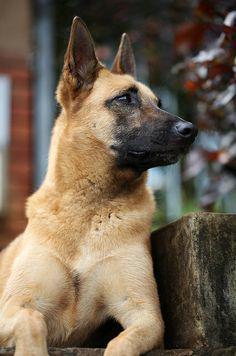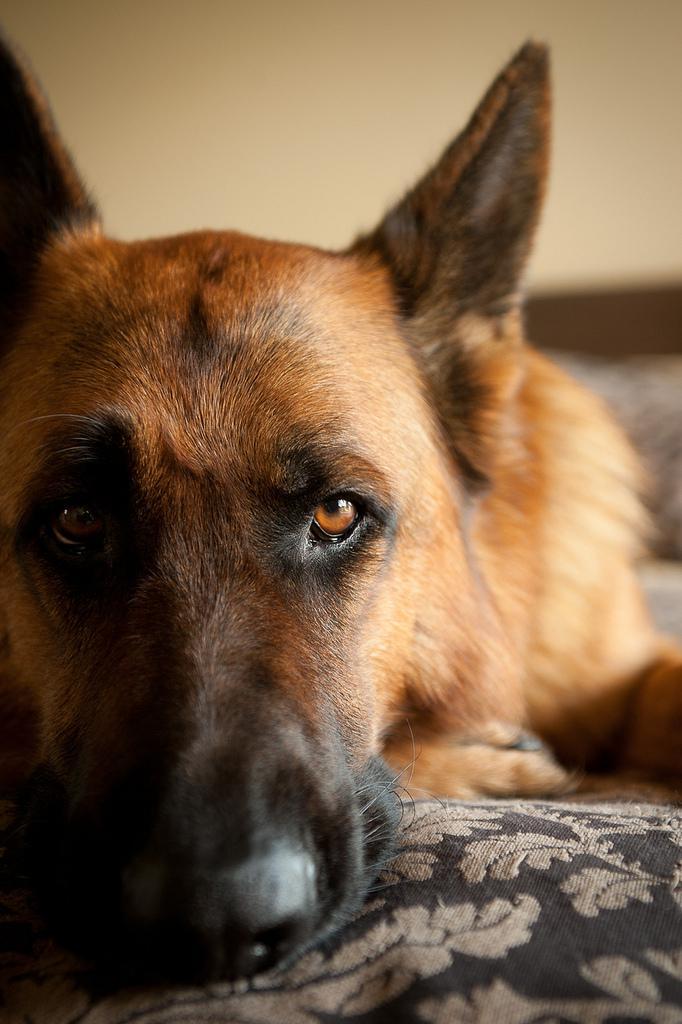The first image is the image on the left, the second image is the image on the right. Evaluate the accuracy of this statement regarding the images: "At least one dog has its tongue out.". Is it true? Answer yes or no. No. 